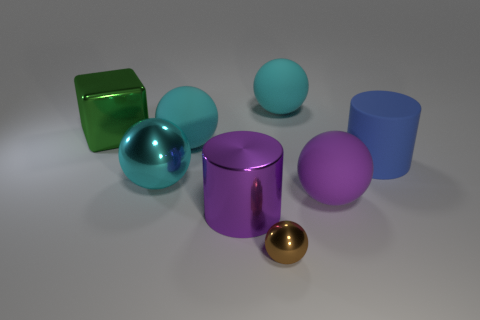There is a big metallic object that is behind the cylinder behind the big purple cylinder; what shape is it?
Make the answer very short. Cube. How many things are either objects that are on the right side of the tiny metallic thing or big rubber spheres that are on the left side of the small metallic ball?
Give a very brief answer. 4. What is the shape of the large green thing that is made of the same material as the big purple cylinder?
Offer a very short reply. Cube. Is there any other thing of the same color as the large shiny sphere?
Your answer should be compact. Yes. There is another purple object that is the same shape as the tiny metallic object; what is its material?
Your answer should be compact. Rubber. How many other objects are there of the same size as the purple matte sphere?
Your response must be concise. 6. What material is the large green object?
Keep it short and to the point. Metal. Are there more big blue cylinders in front of the big cyan shiny thing than purple cylinders?
Offer a terse response. No. Are there any small gray blocks?
Offer a very short reply. No. What number of other things are the same shape as the tiny thing?
Provide a short and direct response. 4. 